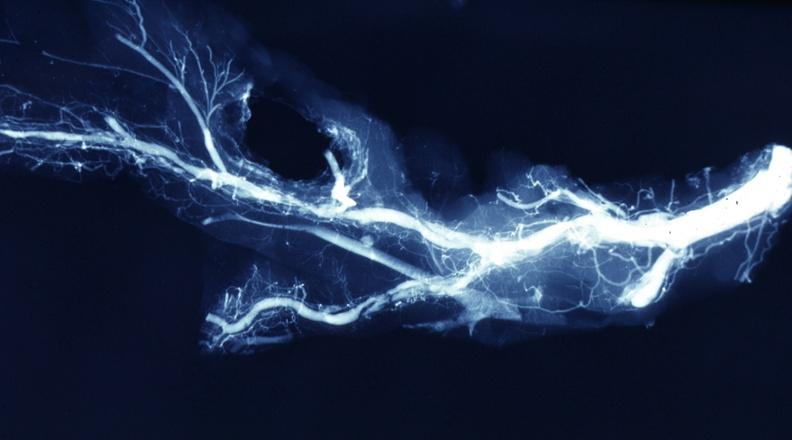where is this from?
Answer the question using a single word or phrase. Vasculature 